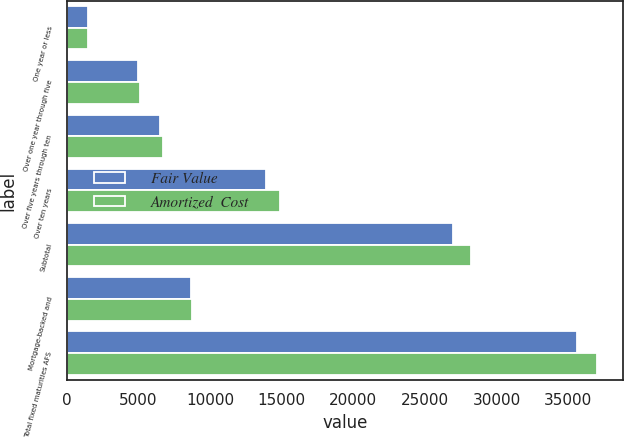Convert chart to OTSL. <chart><loc_0><loc_0><loc_500><loc_500><stacked_bar_chart><ecel><fcel>One year or less<fcel>Over one year through five<fcel>Over five years through ten<fcel>Over ten years<fcel>Subtotal<fcel>Mortgage-backed and<fcel>Total fixed maturities AFS<nl><fcel>Fair Value<fcel>1507<fcel>5007<fcel>6505<fcel>13928<fcel>26947<fcel>8665<fcel>35612<nl><fcel>Amortized  Cost<fcel>1513<fcel>5119<fcel>6700<fcel>14866<fcel>28198<fcel>8766<fcel>36964<nl></chart> 